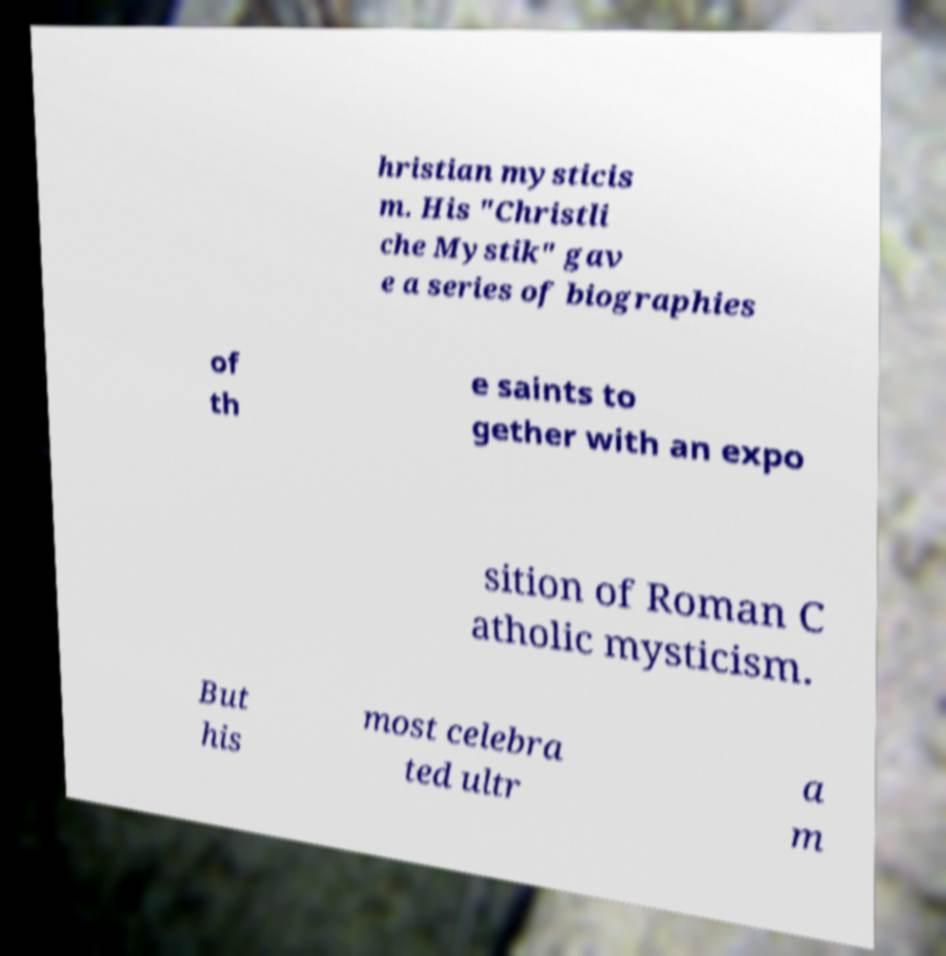There's text embedded in this image that I need extracted. Can you transcribe it verbatim? hristian mysticis m. His "Christli che Mystik" gav e a series of biographies of th e saints to gether with an expo sition of Roman C atholic mysticism. But his most celebra ted ultr a m 